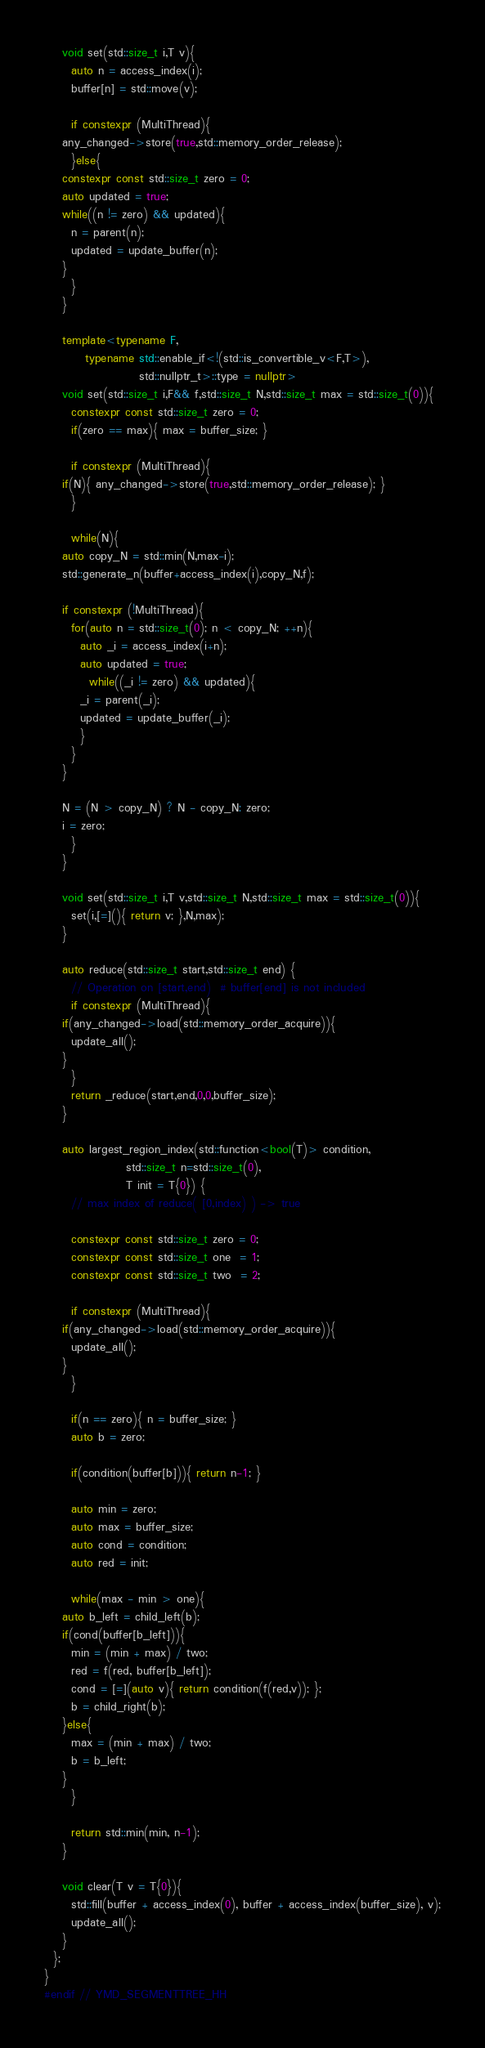<code> <loc_0><loc_0><loc_500><loc_500><_C++_>
    void set(std::size_t i,T v){
      auto n = access_index(i);
      buffer[n] = std::move(v);

      if constexpr (MultiThread){
	any_changed->store(true,std::memory_order_release);
      }else{
	constexpr const std::size_t zero = 0;
	auto updated = true;
	while((n != zero) && updated){
	  n = parent(n);
	  updated = update_buffer(n);
	}
      }
    }

    template<typename F,
	     typename std::enable_if<!(std::is_convertible_v<F,T>),
				     std::nullptr_t>::type = nullptr>
    void set(std::size_t i,F&& f,std::size_t N,std::size_t max = std::size_t(0)){
      constexpr const std::size_t zero = 0;
      if(zero == max){ max = buffer_size; }

      if constexpr (MultiThread){
	if(N){ any_changed->store(true,std::memory_order_release); }
      }

      while(N){
	auto copy_N = std::min(N,max-i);
	std::generate_n(buffer+access_index(i),copy_N,f);

	if constexpr (!MultiThread){
	  for(auto n = std::size_t(0); n < copy_N; ++n){
	    auto _i = access_index(i+n);
	    auto updated = true;
	      while((_i != zero) && updated){
		_i = parent(_i);
		updated = update_buffer(_i);
	    }
	  }
	}

	N = (N > copy_N) ? N - copy_N: zero;
	i = zero;
      }
    }

    void set(std::size_t i,T v,std::size_t N,std::size_t max = std::size_t(0)){
      set(i,[=](){ return v; },N,max);
    }

    auto reduce(std::size_t start,std::size_t end) {
      // Operation on [start,end)  # buffer[end] is not included
      if constexpr (MultiThread){
	if(any_changed->load(std::memory_order_acquire)){
	  update_all();
	}
      }
      return _reduce(start,end,0,0,buffer_size);
    }

    auto largest_region_index(std::function<bool(T)> condition,
			      std::size_t n=std::size_t(0),
			      T init = T{0}) {
      // max index of reduce( [0,index) ) -> true

      constexpr const std::size_t zero = 0;
      constexpr const std::size_t one  = 1;
      constexpr const std::size_t two  = 2;

      if constexpr (MultiThread){
	if(any_changed->load(std::memory_order_acquire)){
	  update_all();
	}
      }

      if(n == zero){ n = buffer_size; }
      auto b = zero;

      if(condition(buffer[b])){ return n-1; }

      auto min = zero;
      auto max = buffer_size;
      auto cond = condition;
      auto red = init;

      while(max - min > one){
	auto b_left = child_left(b);
	if(cond(buffer[b_left])){
	  min = (min + max) / two;
	  red = f(red, buffer[b_left]);
	  cond = [=](auto v){ return condition(f(red,v)); };
	  b = child_right(b);
	}else{
	  max = (min + max) / two;
	  b = b_left;
	}
      }

      return std::min(min, n-1);
    }

    void clear(T v = T{0}){
      std::fill(buffer + access_index(0), buffer + access_index(buffer_size), v);
      update_all();
    }
  };
}
#endif // YMD_SEGMENTTREE_HH
</code> 